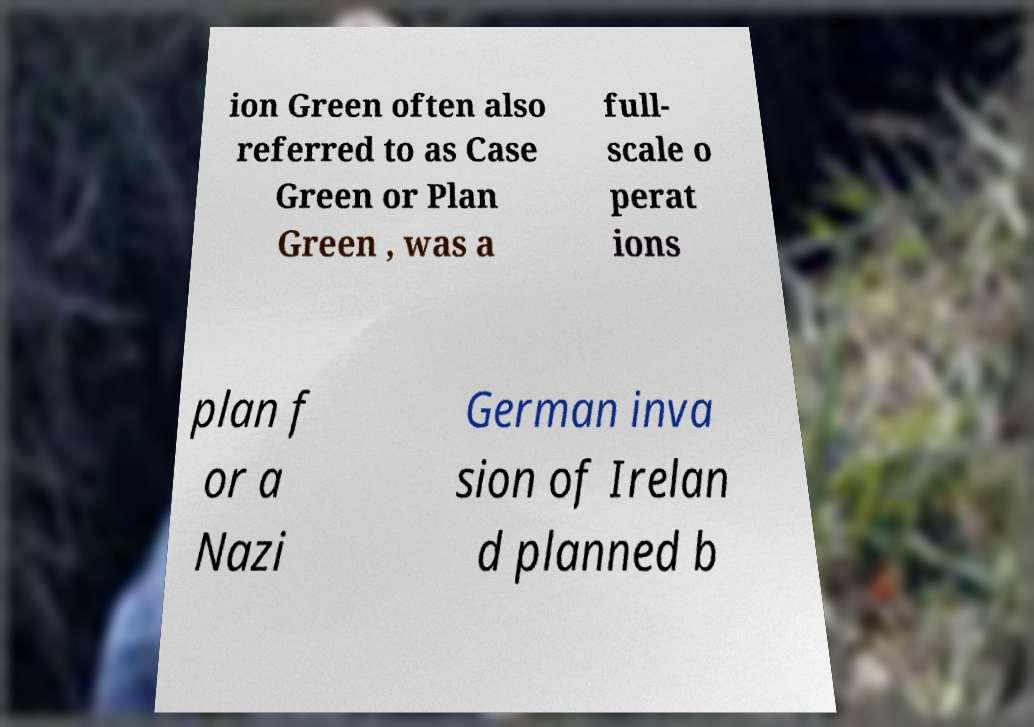Please read and relay the text visible in this image. What does it say? ion Green often also referred to as Case Green or Plan Green , was a full- scale o perat ions plan f or a Nazi German inva sion of Irelan d planned b 